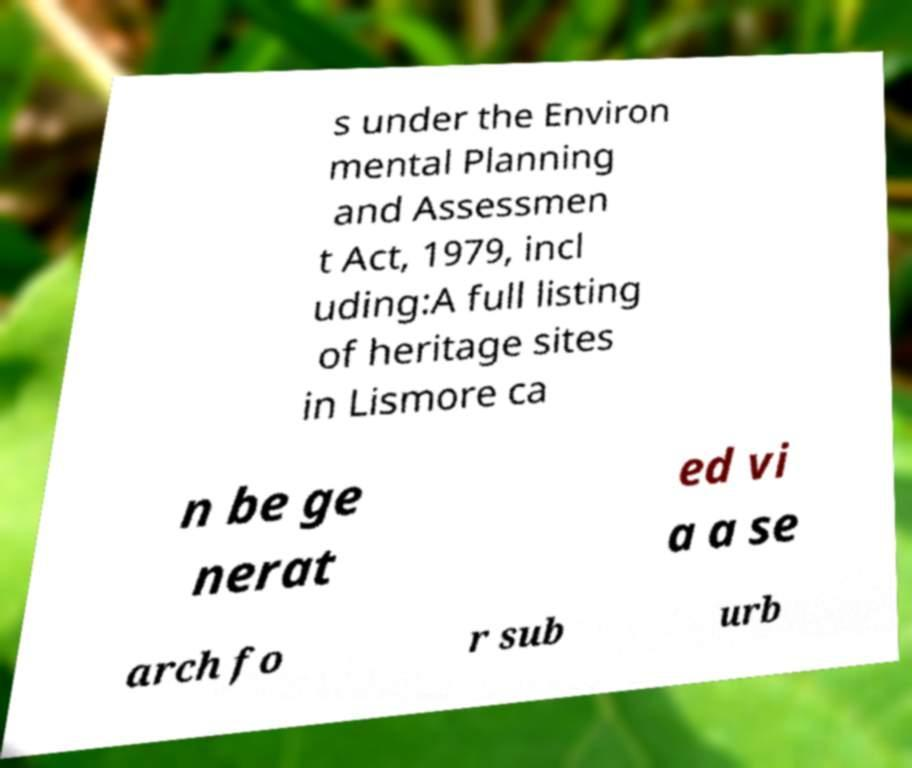Please identify and transcribe the text found in this image. s under the Environ mental Planning and Assessmen t Act, 1979, incl uding:A full listing of heritage sites in Lismore ca n be ge nerat ed vi a a se arch fo r sub urb 